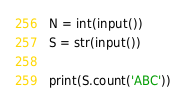<code> <loc_0><loc_0><loc_500><loc_500><_Python_>N = int(input())
S = str(input())

print(S.count('ABC'))</code> 